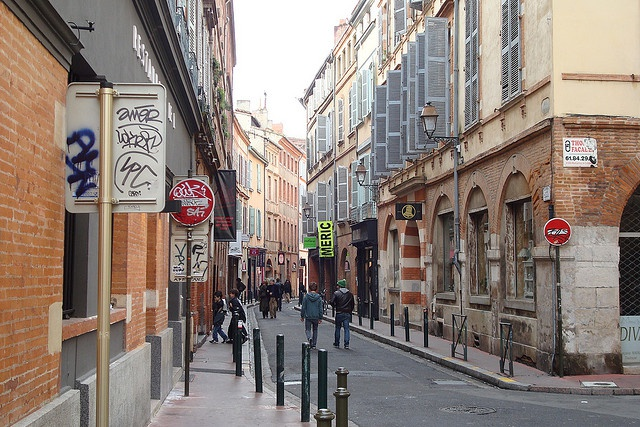Describe the objects in this image and their specific colors. I can see people in black, gray, and blue tones, people in black, navy, blue, and gray tones, stop sign in black, brown, maroon, and lightgray tones, people in black, gray, navy, and darkgray tones, and people in black, gray, darkgray, and lightgray tones in this image. 